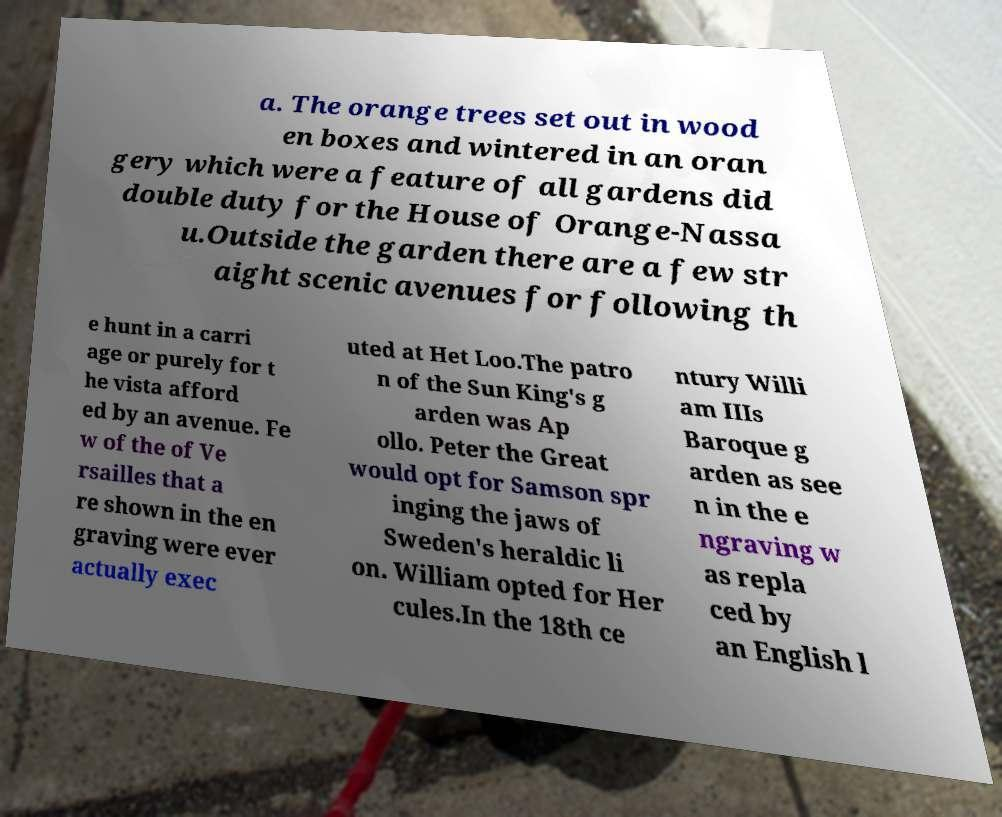There's text embedded in this image that I need extracted. Can you transcribe it verbatim? a. The orange trees set out in wood en boxes and wintered in an oran gery which were a feature of all gardens did double duty for the House of Orange-Nassa u.Outside the garden there are a few str aight scenic avenues for following th e hunt in a carri age or purely for t he vista afford ed by an avenue. Fe w of the of Ve rsailles that a re shown in the en graving were ever actually exec uted at Het Loo.The patro n of the Sun King's g arden was Ap ollo. Peter the Great would opt for Samson spr inging the jaws of Sweden's heraldic li on. William opted for Her cules.In the 18th ce ntury Willi am IIIs Baroque g arden as see n in the e ngraving w as repla ced by an English l 